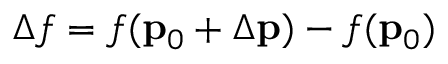<formula> <loc_0><loc_0><loc_500><loc_500>\Delta f = f ( { p } _ { 0 } + \Delta { p } ) - f ( { p } _ { 0 } )</formula> 